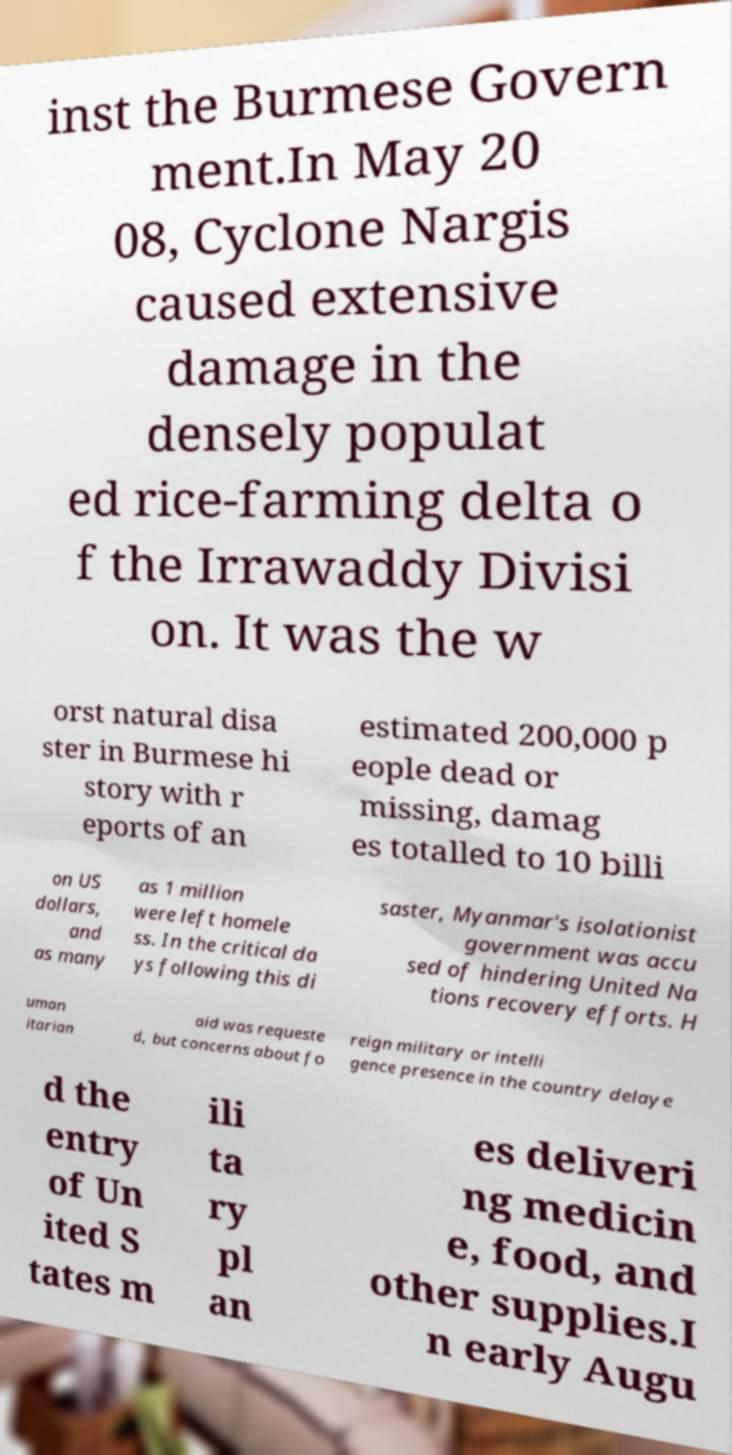Please read and relay the text visible in this image. What does it say? inst the Burmese Govern ment.In May 20 08, Cyclone Nargis caused extensive damage in the densely populat ed rice-farming delta o f the Irrawaddy Divisi on. It was the w orst natural disa ster in Burmese hi story with r eports of an estimated 200,000 p eople dead or missing, damag es totalled to 10 billi on US dollars, and as many as 1 million were left homele ss. In the critical da ys following this di saster, Myanmar's isolationist government was accu sed of hindering United Na tions recovery efforts. H uman itarian aid was requeste d, but concerns about fo reign military or intelli gence presence in the country delaye d the entry of Un ited S tates m ili ta ry pl an es deliveri ng medicin e, food, and other supplies.I n early Augu 